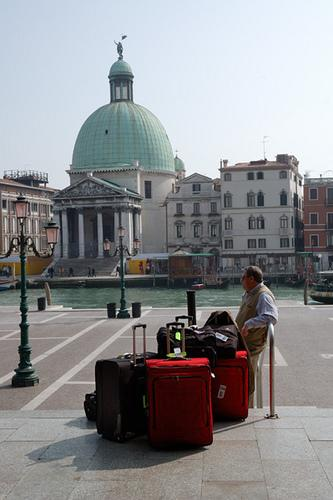What mode of transport did this person recently take advantage of? airplane 